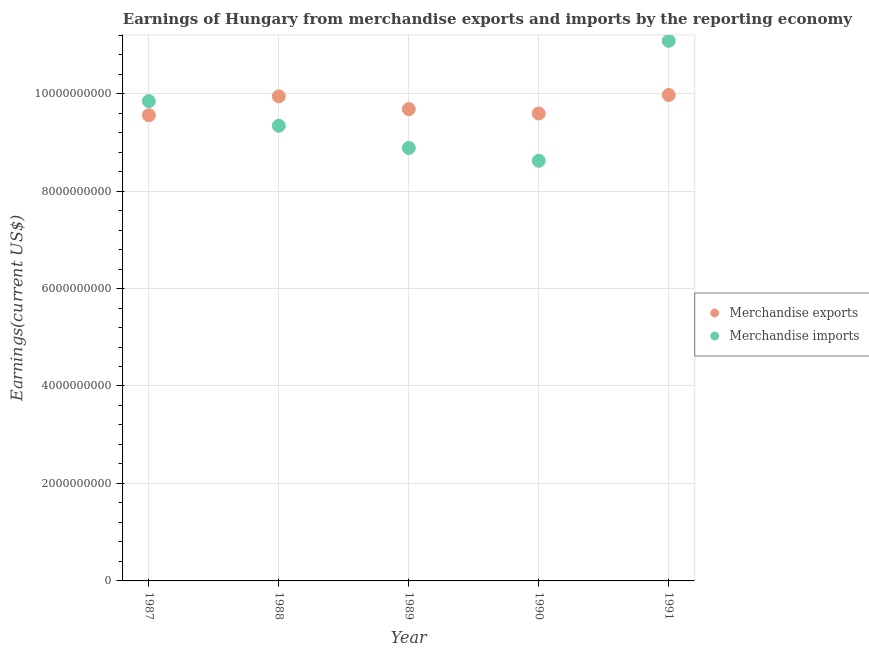What is the earnings from merchandise exports in 1990?
Offer a terse response. 9.59e+09. Across all years, what is the maximum earnings from merchandise exports?
Your answer should be very brief. 9.97e+09. Across all years, what is the minimum earnings from merchandise imports?
Make the answer very short. 8.62e+09. In which year was the earnings from merchandise imports minimum?
Offer a terse response. 1990. What is the total earnings from merchandise exports in the graph?
Your response must be concise. 4.87e+1. What is the difference between the earnings from merchandise exports in 1989 and that in 1990?
Ensure brevity in your answer.  8.95e+07. What is the difference between the earnings from merchandise imports in 1990 and the earnings from merchandise exports in 1991?
Your response must be concise. -1.35e+09. What is the average earnings from merchandise imports per year?
Offer a terse response. 9.55e+09. In the year 1990, what is the difference between the earnings from merchandise exports and earnings from merchandise imports?
Offer a very short reply. 9.71e+08. What is the ratio of the earnings from merchandise exports in 1987 to that in 1990?
Offer a very short reply. 1. Is the earnings from merchandise imports in 1987 less than that in 1988?
Offer a terse response. No. What is the difference between the highest and the second highest earnings from merchandise imports?
Make the answer very short. 1.24e+09. What is the difference between the highest and the lowest earnings from merchandise exports?
Keep it short and to the point. 4.16e+08. In how many years, is the earnings from merchandise imports greater than the average earnings from merchandise imports taken over all years?
Offer a very short reply. 2. Is the sum of the earnings from merchandise imports in 1989 and 1991 greater than the maximum earnings from merchandise exports across all years?
Offer a terse response. Yes. Does the earnings from merchandise exports monotonically increase over the years?
Make the answer very short. No. How many dotlines are there?
Ensure brevity in your answer.  2. How many years are there in the graph?
Ensure brevity in your answer.  5. Does the graph contain grids?
Offer a terse response. Yes. Where does the legend appear in the graph?
Ensure brevity in your answer.  Center right. What is the title of the graph?
Your response must be concise. Earnings of Hungary from merchandise exports and imports by the reporting economy. Does "Age 65(male)" appear as one of the legend labels in the graph?
Give a very brief answer. No. What is the label or title of the Y-axis?
Give a very brief answer. Earnings(current US$). What is the Earnings(current US$) in Merchandise exports in 1987?
Offer a terse response. 9.56e+09. What is the Earnings(current US$) in Merchandise imports in 1987?
Make the answer very short. 9.85e+09. What is the Earnings(current US$) of Merchandise exports in 1988?
Your answer should be very brief. 9.94e+09. What is the Earnings(current US$) of Merchandise imports in 1988?
Ensure brevity in your answer.  9.34e+09. What is the Earnings(current US$) in Merchandise exports in 1989?
Your answer should be very brief. 9.68e+09. What is the Earnings(current US$) of Merchandise imports in 1989?
Your response must be concise. 8.89e+09. What is the Earnings(current US$) of Merchandise exports in 1990?
Provide a short and direct response. 9.59e+09. What is the Earnings(current US$) of Merchandise imports in 1990?
Give a very brief answer. 8.62e+09. What is the Earnings(current US$) in Merchandise exports in 1991?
Give a very brief answer. 9.97e+09. What is the Earnings(current US$) in Merchandise imports in 1991?
Provide a short and direct response. 1.11e+1. Across all years, what is the maximum Earnings(current US$) of Merchandise exports?
Make the answer very short. 9.97e+09. Across all years, what is the maximum Earnings(current US$) in Merchandise imports?
Make the answer very short. 1.11e+1. Across all years, what is the minimum Earnings(current US$) in Merchandise exports?
Ensure brevity in your answer.  9.56e+09. Across all years, what is the minimum Earnings(current US$) of Merchandise imports?
Your answer should be compact. 8.62e+09. What is the total Earnings(current US$) in Merchandise exports in the graph?
Make the answer very short. 4.87e+1. What is the total Earnings(current US$) of Merchandise imports in the graph?
Keep it short and to the point. 4.78e+1. What is the difference between the Earnings(current US$) in Merchandise exports in 1987 and that in 1988?
Make the answer very short. -3.88e+08. What is the difference between the Earnings(current US$) of Merchandise imports in 1987 and that in 1988?
Offer a very short reply. 5.05e+08. What is the difference between the Earnings(current US$) of Merchandise exports in 1987 and that in 1989?
Offer a terse response. -1.27e+08. What is the difference between the Earnings(current US$) of Merchandise imports in 1987 and that in 1989?
Keep it short and to the point. 9.60e+08. What is the difference between the Earnings(current US$) of Merchandise exports in 1987 and that in 1990?
Make the answer very short. -3.71e+07. What is the difference between the Earnings(current US$) of Merchandise imports in 1987 and that in 1990?
Make the answer very short. 1.22e+09. What is the difference between the Earnings(current US$) of Merchandise exports in 1987 and that in 1991?
Your answer should be compact. -4.16e+08. What is the difference between the Earnings(current US$) of Merchandise imports in 1987 and that in 1991?
Make the answer very short. -1.24e+09. What is the difference between the Earnings(current US$) in Merchandise exports in 1988 and that in 1989?
Your answer should be compact. 2.62e+08. What is the difference between the Earnings(current US$) of Merchandise imports in 1988 and that in 1989?
Your response must be concise. 4.55e+08. What is the difference between the Earnings(current US$) in Merchandise exports in 1988 and that in 1990?
Your response must be concise. 3.51e+08. What is the difference between the Earnings(current US$) of Merchandise imports in 1988 and that in 1990?
Your answer should be compact. 7.19e+08. What is the difference between the Earnings(current US$) of Merchandise exports in 1988 and that in 1991?
Your response must be concise. -2.77e+07. What is the difference between the Earnings(current US$) of Merchandise imports in 1988 and that in 1991?
Provide a short and direct response. -1.74e+09. What is the difference between the Earnings(current US$) of Merchandise exports in 1989 and that in 1990?
Your response must be concise. 8.95e+07. What is the difference between the Earnings(current US$) in Merchandise imports in 1989 and that in 1990?
Provide a succinct answer. 2.64e+08. What is the difference between the Earnings(current US$) of Merchandise exports in 1989 and that in 1991?
Make the answer very short. -2.89e+08. What is the difference between the Earnings(current US$) in Merchandise imports in 1989 and that in 1991?
Give a very brief answer. -2.20e+09. What is the difference between the Earnings(current US$) in Merchandise exports in 1990 and that in 1991?
Your answer should be very brief. -3.79e+08. What is the difference between the Earnings(current US$) in Merchandise imports in 1990 and that in 1991?
Make the answer very short. -2.46e+09. What is the difference between the Earnings(current US$) in Merchandise exports in 1987 and the Earnings(current US$) in Merchandise imports in 1988?
Your response must be concise. 2.15e+08. What is the difference between the Earnings(current US$) in Merchandise exports in 1987 and the Earnings(current US$) in Merchandise imports in 1989?
Offer a very short reply. 6.70e+08. What is the difference between the Earnings(current US$) in Merchandise exports in 1987 and the Earnings(current US$) in Merchandise imports in 1990?
Provide a short and direct response. 9.34e+08. What is the difference between the Earnings(current US$) in Merchandise exports in 1987 and the Earnings(current US$) in Merchandise imports in 1991?
Provide a short and direct response. -1.53e+09. What is the difference between the Earnings(current US$) of Merchandise exports in 1988 and the Earnings(current US$) of Merchandise imports in 1989?
Your answer should be compact. 1.06e+09. What is the difference between the Earnings(current US$) in Merchandise exports in 1988 and the Earnings(current US$) in Merchandise imports in 1990?
Offer a terse response. 1.32e+09. What is the difference between the Earnings(current US$) of Merchandise exports in 1988 and the Earnings(current US$) of Merchandise imports in 1991?
Keep it short and to the point. -1.14e+09. What is the difference between the Earnings(current US$) of Merchandise exports in 1989 and the Earnings(current US$) of Merchandise imports in 1990?
Give a very brief answer. 1.06e+09. What is the difference between the Earnings(current US$) of Merchandise exports in 1989 and the Earnings(current US$) of Merchandise imports in 1991?
Keep it short and to the point. -1.40e+09. What is the difference between the Earnings(current US$) in Merchandise exports in 1990 and the Earnings(current US$) in Merchandise imports in 1991?
Your response must be concise. -1.49e+09. What is the average Earnings(current US$) of Merchandise exports per year?
Provide a short and direct response. 9.75e+09. What is the average Earnings(current US$) in Merchandise imports per year?
Make the answer very short. 9.55e+09. In the year 1987, what is the difference between the Earnings(current US$) in Merchandise exports and Earnings(current US$) in Merchandise imports?
Give a very brief answer. -2.89e+08. In the year 1988, what is the difference between the Earnings(current US$) of Merchandise exports and Earnings(current US$) of Merchandise imports?
Make the answer very short. 6.04e+08. In the year 1989, what is the difference between the Earnings(current US$) in Merchandise exports and Earnings(current US$) in Merchandise imports?
Your answer should be compact. 7.97e+08. In the year 1990, what is the difference between the Earnings(current US$) in Merchandise exports and Earnings(current US$) in Merchandise imports?
Your answer should be very brief. 9.71e+08. In the year 1991, what is the difference between the Earnings(current US$) in Merchandise exports and Earnings(current US$) in Merchandise imports?
Your answer should be compact. -1.11e+09. What is the ratio of the Earnings(current US$) of Merchandise exports in 1987 to that in 1988?
Give a very brief answer. 0.96. What is the ratio of the Earnings(current US$) of Merchandise imports in 1987 to that in 1988?
Give a very brief answer. 1.05. What is the ratio of the Earnings(current US$) of Merchandise exports in 1987 to that in 1989?
Make the answer very short. 0.99. What is the ratio of the Earnings(current US$) in Merchandise imports in 1987 to that in 1989?
Make the answer very short. 1.11. What is the ratio of the Earnings(current US$) of Merchandise exports in 1987 to that in 1990?
Give a very brief answer. 1. What is the ratio of the Earnings(current US$) in Merchandise imports in 1987 to that in 1990?
Give a very brief answer. 1.14. What is the ratio of the Earnings(current US$) in Merchandise imports in 1987 to that in 1991?
Your answer should be compact. 0.89. What is the ratio of the Earnings(current US$) in Merchandise exports in 1988 to that in 1989?
Give a very brief answer. 1.03. What is the ratio of the Earnings(current US$) of Merchandise imports in 1988 to that in 1989?
Offer a very short reply. 1.05. What is the ratio of the Earnings(current US$) in Merchandise exports in 1988 to that in 1990?
Ensure brevity in your answer.  1.04. What is the ratio of the Earnings(current US$) of Merchandise imports in 1988 to that in 1990?
Keep it short and to the point. 1.08. What is the ratio of the Earnings(current US$) in Merchandise exports in 1988 to that in 1991?
Keep it short and to the point. 1. What is the ratio of the Earnings(current US$) of Merchandise imports in 1988 to that in 1991?
Offer a terse response. 0.84. What is the ratio of the Earnings(current US$) in Merchandise exports in 1989 to that in 1990?
Offer a terse response. 1.01. What is the ratio of the Earnings(current US$) in Merchandise imports in 1989 to that in 1990?
Offer a very short reply. 1.03. What is the ratio of the Earnings(current US$) in Merchandise imports in 1989 to that in 1991?
Ensure brevity in your answer.  0.8. What is the ratio of the Earnings(current US$) of Merchandise exports in 1990 to that in 1991?
Provide a succinct answer. 0.96. What is the ratio of the Earnings(current US$) of Merchandise imports in 1990 to that in 1991?
Offer a terse response. 0.78. What is the difference between the highest and the second highest Earnings(current US$) in Merchandise exports?
Your answer should be compact. 2.77e+07. What is the difference between the highest and the second highest Earnings(current US$) in Merchandise imports?
Provide a succinct answer. 1.24e+09. What is the difference between the highest and the lowest Earnings(current US$) of Merchandise exports?
Provide a short and direct response. 4.16e+08. What is the difference between the highest and the lowest Earnings(current US$) in Merchandise imports?
Offer a terse response. 2.46e+09. 